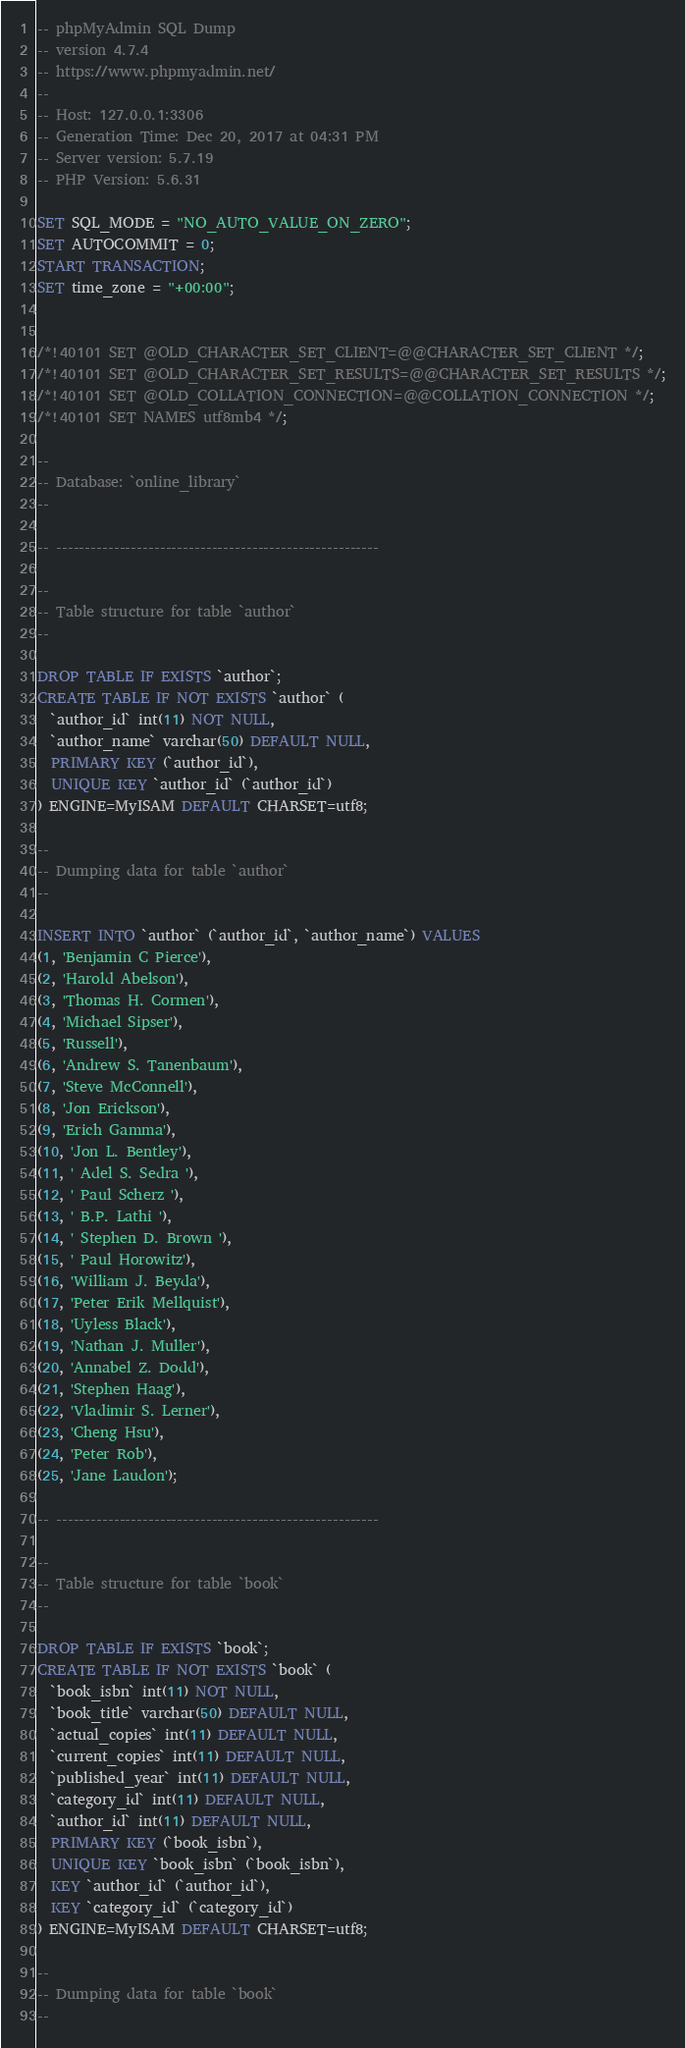Convert code to text. <code><loc_0><loc_0><loc_500><loc_500><_SQL_>-- phpMyAdmin SQL Dump
-- version 4.7.4
-- https://www.phpmyadmin.net/
--
-- Host: 127.0.0.1:3306
-- Generation Time: Dec 20, 2017 at 04:31 PM
-- Server version: 5.7.19
-- PHP Version: 5.6.31

SET SQL_MODE = "NO_AUTO_VALUE_ON_ZERO";
SET AUTOCOMMIT = 0;
START TRANSACTION;
SET time_zone = "+00:00";


/*!40101 SET @OLD_CHARACTER_SET_CLIENT=@@CHARACTER_SET_CLIENT */;
/*!40101 SET @OLD_CHARACTER_SET_RESULTS=@@CHARACTER_SET_RESULTS */;
/*!40101 SET @OLD_COLLATION_CONNECTION=@@COLLATION_CONNECTION */;
/*!40101 SET NAMES utf8mb4 */;

--
-- Database: `online_library`
--

-- --------------------------------------------------------

--
-- Table structure for table `author`
--

DROP TABLE IF EXISTS `author`;
CREATE TABLE IF NOT EXISTS `author` (
  `author_id` int(11) NOT NULL,
  `author_name` varchar(50) DEFAULT NULL,
  PRIMARY KEY (`author_id`),
  UNIQUE KEY `author_id` (`author_id`)
) ENGINE=MyISAM DEFAULT CHARSET=utf8;

--
-- Dumping data for table `author`
--

INSERT INTO `author` (`author_id`, `author_name`) VALUES
(1, 'Benjamin C Pierce'),
(2, 'Harold Abelson'),
(3, 'Thomas H. Cormen'),
(4, 'Michael Sipser'),
(5, 'Russell'),
(6, 'Andrew S. Tanenbaum'),
(7, 'Steve McConnell'),
(8, 'Jon Erickson'),
(9, 'Erich Gamma'),
(10, 'Jon L. Bentley'),
(11, ' Adel S. Sedra '),
(12, ' Paul Scherz '),
(13, ' B.P. Lathi '),
(14, ' Stephen D. Brown '),
(15, ' Paul Horowitz'),
(16, 'William J. Beyda'),
(17, 'Peter Erik Mellquist'),
(18, 'Uyless Black'),
(19, 'Nathan J. Muller'),
(20, 'Annabel Z. Dodd'),
(21, 'Stephen Haag'),
(22, 'Vladimir S. Lerner'),
(23, 'Cheng Hsu'),
(24, 'Peter Rob'),
(25, 'Jane Laudon');

-- --------------------------------------------------------

--
-- Table structure for table `book`
--

DROP TABLE IF EXISTS `book`;
CREATE TABLE IF NOT EXISTS `book` (
  `book_isbn` int(11) NOT NULL,
  `book_title` varchar(50) DEFAULT NULL,
  `actual_copies` int(11) DEFAULT NULL,
  `current_copies` int(11) DEFAULT NULL,
  `published_year` int(11) DEFAULT NULL,
  `category_id` int(11) DEFAULT NULL,
  `author_id` int(11) DEFAULT NULL,
  PRIMARY KEY (`book_isbn`),
  UNIQUE KEY `book_isbn` (`book_isbn`),
  KEY `author_id` (`author_id`),
  KEY `category_id` (`category_id`)
) ENGINE=MyISAM DEFAULT CHARSET=utf8;

--
-- Dumping data for table `book`
--
</code> 